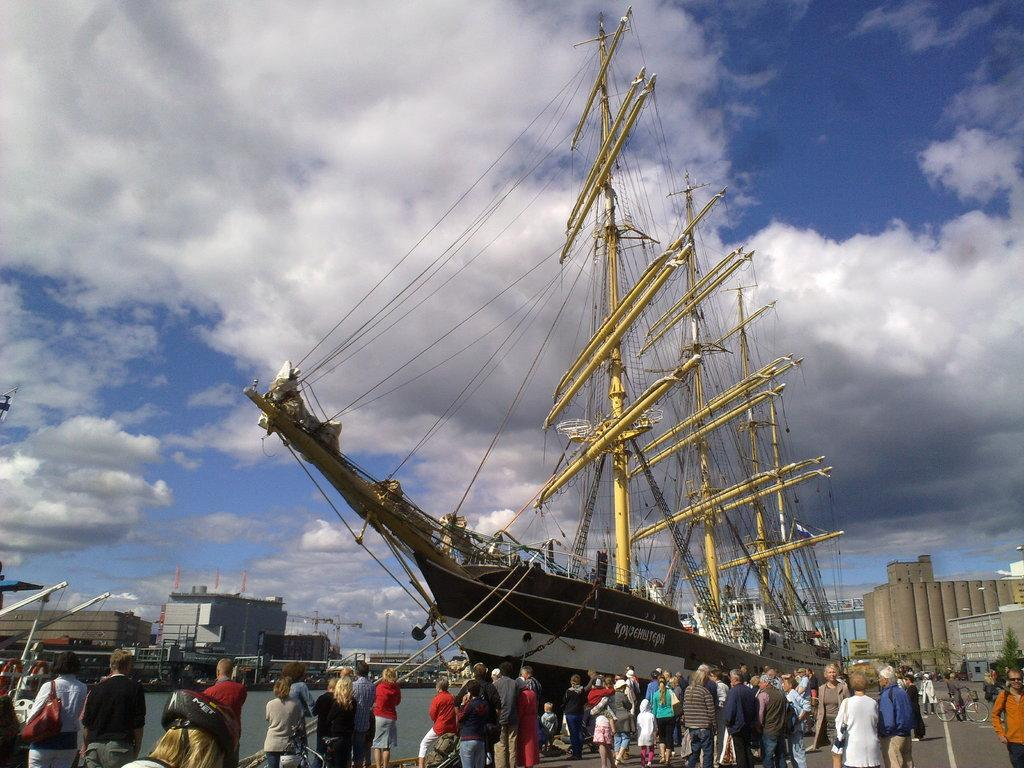Who or what is present in the image? There are people in the image. What type of vehicle is in the image? There is a boat in the image. What structures can be seen in the image? There are buildings in the image. What natural element is visible in the image? There is water visible in the image. What is visible in the background of the image? The sky is visible in the image, and clouds are present in the sky. How many pizzas are being served to the goose by the dad in the image? There is no goose or dad present in the image, and no pizzas are being served. 